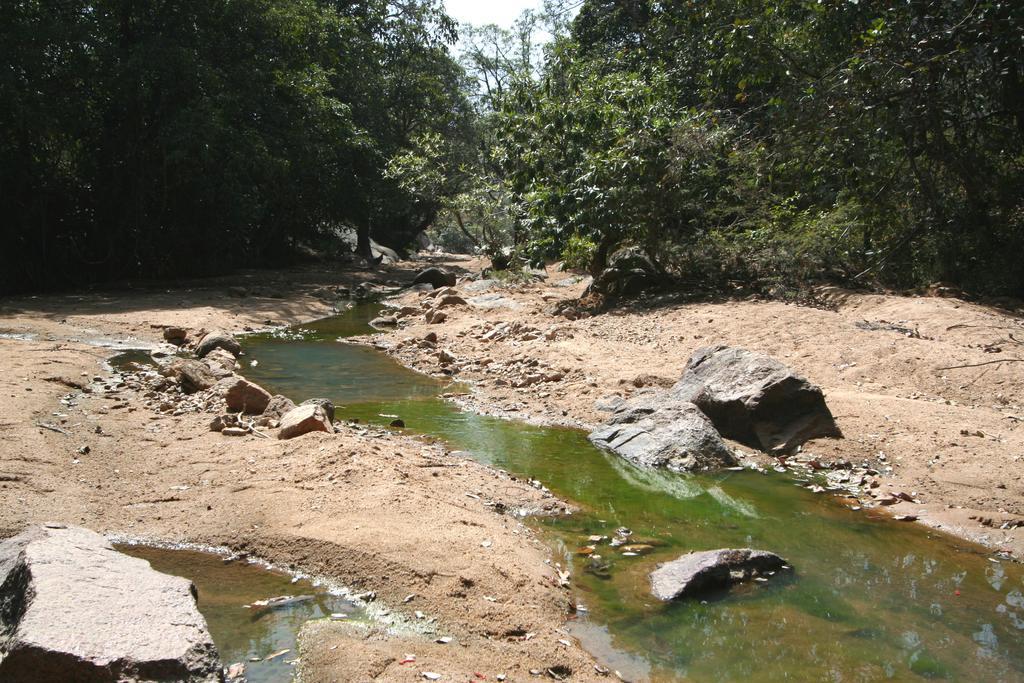In one or two sentences, can you explain what this image depicts? In this image we can see water, there are some stones, trees and rocks, in the background we can see the sky. 